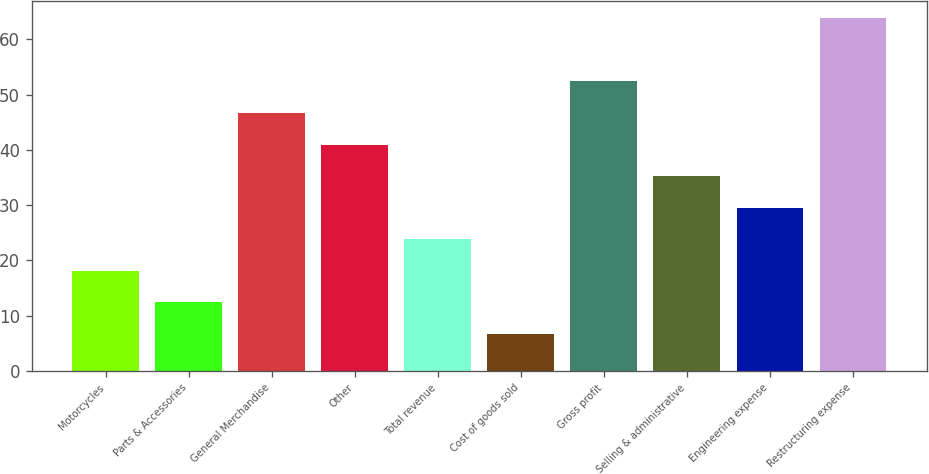<chart> <loc_0><loc_0><loc_500><loc_500><bar_chart><fcel>Motorcycles<fcel>Parts & Accessories<fcel>General Merchandise<fcel>Other<fcel>Total revenue<fcel>Cost of goods sold<fcel>Gross profit<fcel>Selling & administrative<fcel>Engineering expense<fcel>Restructuring expense<nl><fcel>18.13<fcel>12.42<fcel>46.68<fcel>40.97<fcel>23.84<fcel>6.71<fcel>52.39<fcel>35.26<fcel>29.55<fcel>63.81<nl></chart> 